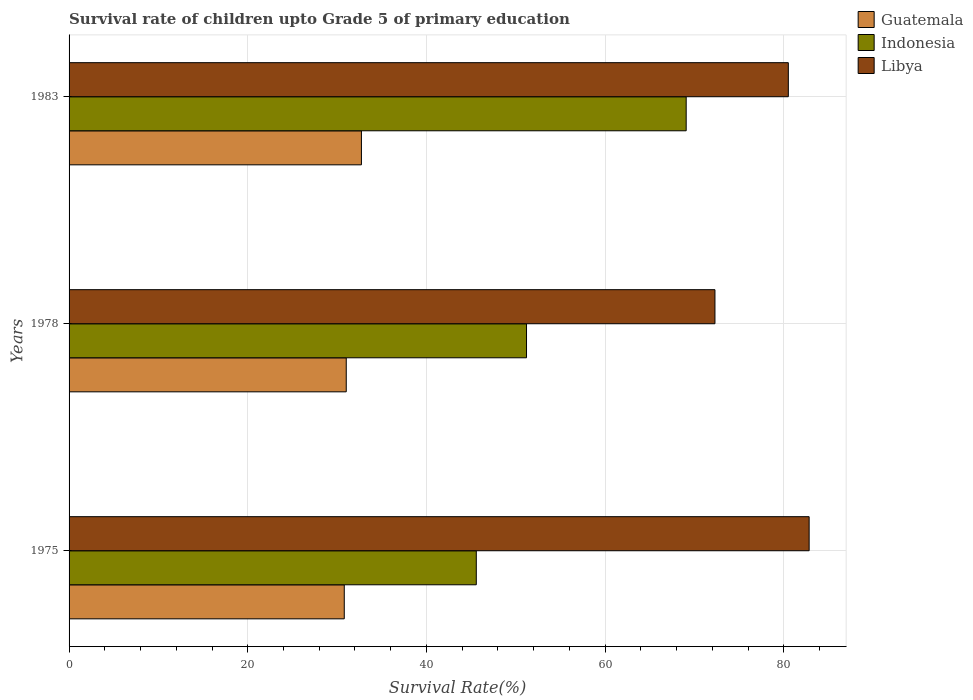How many bars are there on the 1st tick from the top?
Make the answer very short. 3. In how many cases, is the number of bars for a given year not equal to the number of legend labels?
Offer a terse response. 0. What is the survival rate of children in Libya in 1983?
Your answer should be compact. 80.51. Across all years, what is the maximum survival rate of children in Guatemala?
Your answer should be compact. 32.73. Across all years, what is the minimum survival rate of children in Indonesia?
Keep it short and to the point. 45.58. In which year was the survival rate of children in Indonesia minimum?
Give a very brief answer. 1975. What is the total survival rate of children in Indonesia in the graph?
Your response must be concise. 165.87. What is the difference between the survival rate of children in Libya in 1975 and that in 1978?
Provide a short and direct response. 10.54. What is the difference between the survival rate of children in Guatemala in 1978 and the survival rate of children in Indonesia in 1975?
Your response must be concise. -14.56. What is the average survival rate of children in Libya per year?
Your answer should be compact. 78.55. In the year 1983, what is the difference between the survival rate of children in Libya and survival rate of children in Guatemala?
Provide a succinct answer. 47.79. What is the ratio of the survival rate of children in Indonesia in 1978 to that in 1983?
Provide a succinct answer. 0.74. Is the survival rate of children in Libya in 1975 less than that in 1978?
Your answer should be compact. No. Is the difference between the survival rate of children in Libya in 1975 and 1983 greater than the difference between the survival rate of children in Guatemala in 1975 and 1983?
Offer a terse response. Yes. What is the difference between the highest and the second highest survival rate of children in Libya?
Your answer should be very brief. 2.33. What is the difference between the highest and the lowest survival rate of children in Libya?
Make the answer very short. 10.54. What does the 1st bar from the top in 1975 represents?
Your answer should be compact. Libya. What does the 3rd bar from the bottom in 1983 represents?
Offer a very short reply. Libya. Is it the case that in every year, the sum of the survival rate of children in Guatemala and survival rate of children in Libya is greater than the survival rate of children in Indonesia?
Offer a very short reply. Yes. How many bars are there?
Offer a terse response. 9. Are all the bars in the graph horizontal?
Your answer should be compact. Yes. What is the difference between two consecutive major ticks on the X-axis?
Offer a terse response. 20. Are the values on the major ticks of X-axis written in scientific E-notation?
Provide a short and direct response. No. Does the graph contain any zero values?
Provide a short and direct response. No. What is the title of the graph?
Offer a very short reply. Survival rate of children upto Grade 5 of primary education. What is the label or title of the X-axis?
Provide a succinct answer. Survival Rate(%). What is the Survival Rate(%) of Guatemala in 1975?
Ensure brevity in your answer.  30.81. What is the Survival Rate(%) in Indonesia in 1975?
Offer a very short reply. 45.58. What is the Survival Rate(%) of Libya in 1975?
Your answer should be very brief. 82.84. What is the Survival Rate(%) of Guatemala in 1978?
Offer a terse response. 31.03. What is the Survival Rate(%) in Indonesia in 1978?
Give a very brief answer. 51.21. What is the Survival Rate(%) of Libya in 1978?
Your response must be concise. 72.3. What is the Survival Rate(%) of Guatemala in 1983?
Ensure brevity in your answer.  32.73. What is the Survival Rate(%) of Indonesia in 1983?
Your response must be concise. 69.08. What is the Survival Rate(%) of Libya in 1983?
Offer a very short reply. 80.51. Across all years, what is the maximum Survival Rate(%) in Guatemala?
Offer a terse response. 32.73. Across all years, what is the maximum Survival Rate(%) in Indonesia?
Make the answer very short. 69.08. Across all years, what is the maximum Survival Rate(%) of Libya?
Keep it short and to the point. 82.84. Across all years, what is the minimum Survival Rate(%) in Guatemala?
Your answer should be compact. 30.81. Across all years, what is the minimum Survival Rate(%) of Indonesia?
Give a very brief answer. 45.58. Across all years, what is the minimum Survival Rate(%) in Libya?
Offer a terse response. 72.3. What is the total Survival Rate(%) of Guatemala in the graph?
Your answer should be very brief. 94.56. What is the total Survival Rate(%) of Indonesia in the graph?
Your response must be concise. 165.87. What is the total Survival Rate(%) in Libya in the graph?
Your answer should be compact. 235.66. What is the difference between the Survival Rate(%) in Guatemala in 1975 and that in 1978?
Keep it short and to the point. -0.22. What is the difference between the Survival Rate(%) in Indonesia in 1975 and that in 1978?
Keep it short and to the point. -5.62. What is the difference between the Survival Rate(%) in Libya in 1975 and that in 1978?
Your response must be concise. 10.54. What is the difference between the Survival Rate(%) of Guatemala in 1975 and that in 1983?
Provide a succinct answer. -1.92. What is the difference between the Survival Rate(%) in Indonesia in 1975 and that in 1983?
Give a very brief answer. -23.5. What is the difference between the Survival Rate(%) in Libya in 1975 and that in 1983?
Provide a succinct answer. 2.33. What is the difference between the Survival Rate(%) of Guatemala in 1978 and that in 1983?
Give a very brief answer. -1.7. What is the difference between the Survival Rate(%) of Indonesia in 1978 and that in 1983?
Your response must be concise. -17.87. What is the difference between the Survival Rate(%) of Libya in 1978 and that in 1983?
Your answer should be very brief. -8.21. What is the difference between the Survival Rate(%) of Guatemala in 1975 and the Survival Rate(%) of Indonesia in 1978?
Ensure brevity in your answer.  -20.4. What is the difference between the Survival Rate(%) in Guatemala in 1975 and the Survival Rate(%) in Libya in 1978?
Your response must be concise. -41.49. What is the difference between the Survival Rate(%) of Indonesia in 1975 and the Survival Rate(%) of Libya in 1978?
Give a very brief answer. -26.72. What is the difference between the Survival Rate(%) in Guatemala in 1975 and the Survival Rate(%) in Indonesia in 1983?
Provide a succinct answer. -38.27. What is the difference between the Survival Rate(%) in Guatemala in 1975 and the Survival Rate(%) in Libya in 1983?
Make the answer very short. -49.71. What is the difference between the Survival Rate(%) of Indonesia in 1975 and the Survival Rate(%) of Libya in 1983?
Make the answer very short. -34.93. What is the difference between the Survival Rate(%) in Guatemala in 1978 and the Survival Rate(%) in Indonesia in 1983?
Make the answer very short. -38.05. What is the difference between the Survival Rate(%) in Guatemala in 1978 and the Survival Rate(%) in Libya in 1983?
Your response must be concise. -49.49. What is the difference between the Survival Rate(%) in Indonesia in 1978 and the Survival Rate(%) in Libya in 1983?
Provide a short and direct response. -29.31. What is the average Survival Rate(%) in Guatemala per year?
Your response must be concise. 31.52. What is the average Survival Rate(%) of Indonesia per year?
Offer a terse response. 55.29. What is the average Survival Rate(%) in Libya per year?
Make the answer very short. 78.55. In the year 1975, what is the difference between the Survival Rate(%) of Guatemala and Survival Rate(%) of Indonesia?
Keep it short and to the point. -14.78. In the year 1975, what is the difference between the Survival Rate(%) in Guatemala and Survival Rate(%) in Libya?
Make the answer very short. -52.04. In the year 1975, what is the difference between the Survival Rate(%) in Indonesia and Survival Rate(%) in Libya?
Ensure brevity in your answer.  -37.26. In the year 1978, what is the difference between the Survival Rate(%) of Guatemala and Survival Rate(%) of Indonesia?
Offer a very short reply. -20.18. In the year 1978, what is the difference between the Survival Rate(%) in Guatemala and Survival Rate(%) in Libya?
Your response must be concise. -41.27. In the year 1978, what is the difference between the Survival Rate(%) of Indonesia and Survival Rate(%) of Libya?
Offer a terse response. -21.09. In the year 1983, what is the difference between the Survival Rate(%) in Guatemala and Survival Rate(%) in Indonesia?
Offer a very short reply. -36.35. In the year 1983, what is the difference between the Survival Rate(%) of Guatemala and Survival Rate(%) of Libya?
Give a very brief answer. -47.79. In the year 1983, what is the difference between the Survival Rate(%) in Indonesia and Survival Rate(%) in Libya?
Offer a terse response. -11.43. What is the ratio of the Survival Rate(%) in Guatemala in 1975 to that in 1978?
Ensure brevity in your answer.  0.99. What is the ratio of the Survival Rate(%) in Indonesia in 1975 to that in 1978?
Your response must be concise. 0.89. What is the ratio of the Survival Rate(%) in Libya in 1975 to that in 1978?
Offer a terse response. 1.15. What is the ratio of the Survival Rate(%) in Guatemala in 1975 to that in 1983?
Ensure brevity in your answer.  0.94. What is the ratio of the Survival Rate(%) in Indonesia in 1975 to that in 1983?
Offer a terse response. 0.66. What is the ratio of the Survival Rate(%) of Libya in 1975 to that in 1983?
Offer a terse response. 1.03. What is the ratio of the Survival Rate(%) of Guatemala in 1978 to that in 1983?
Make the answer very short. 0.95. What is the ratio of the Survival Rate(%) of Indonesia in 1978 to that in 1983?
Provide a succinct answer. 0.74. What is the ratio of the Survival Rate(%) of Libya in 1978 to that in 1983?
Ensure brevity in your answer.  0.9. What is the difference between the highest and the second highest Survival Rate(%) of Guatemala?
Offer a terse response. 1.7. What is the difference between the highest and the second highest Survival Rate(%) of Indonesia?
Offer a very short reply. 17.87. What is the difference between the highest and the second highest Survival Rate(%) in Libya?
Your answer should be very brief. 2.33. What is the difference between the highest and the lowest Survival Rate(%) in Guatemala?
Offer a terse response. 1.92. What is the difference between the highest and the lowest Survival Rate(%) in Indonesia?
Keep it short and to the point. 23.5. What is the difference between the highest and the lowest Survival Rate(%) of Libya?
Your answer should be very brief. 10.54. 